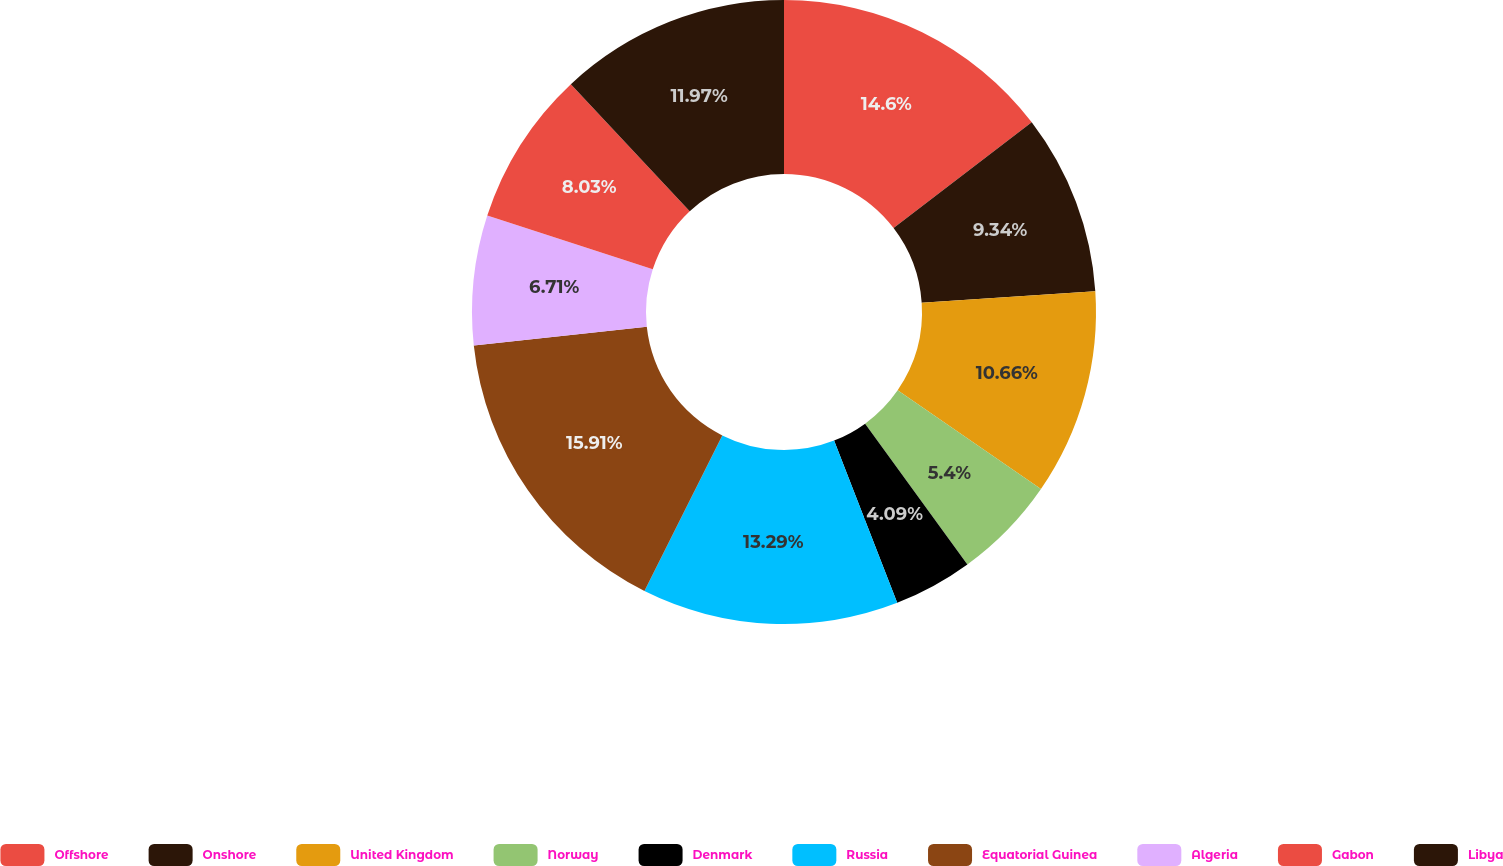Convert chart. <chart><loc_0><loc_0><loc_500><loc_500><pie_chart><fcel>Offshore<fcel>Onshore<fcel>United Kingdom<fcel>Norway<fcel>Denmark<fcel>Russia<fcel>Equatorial Guinea<fcel>Algeria<fcel>Gabon<fcel>Libya<nl><fcel>14.6%<fcel>9.34%<fcel>10.66%<fcel>5.4%<fcel>4.09%<fcel>13.29%<fcel>15.91%<fcel>6.71%<fcel>8.03%<fcel>11.97%<nl></chart> 